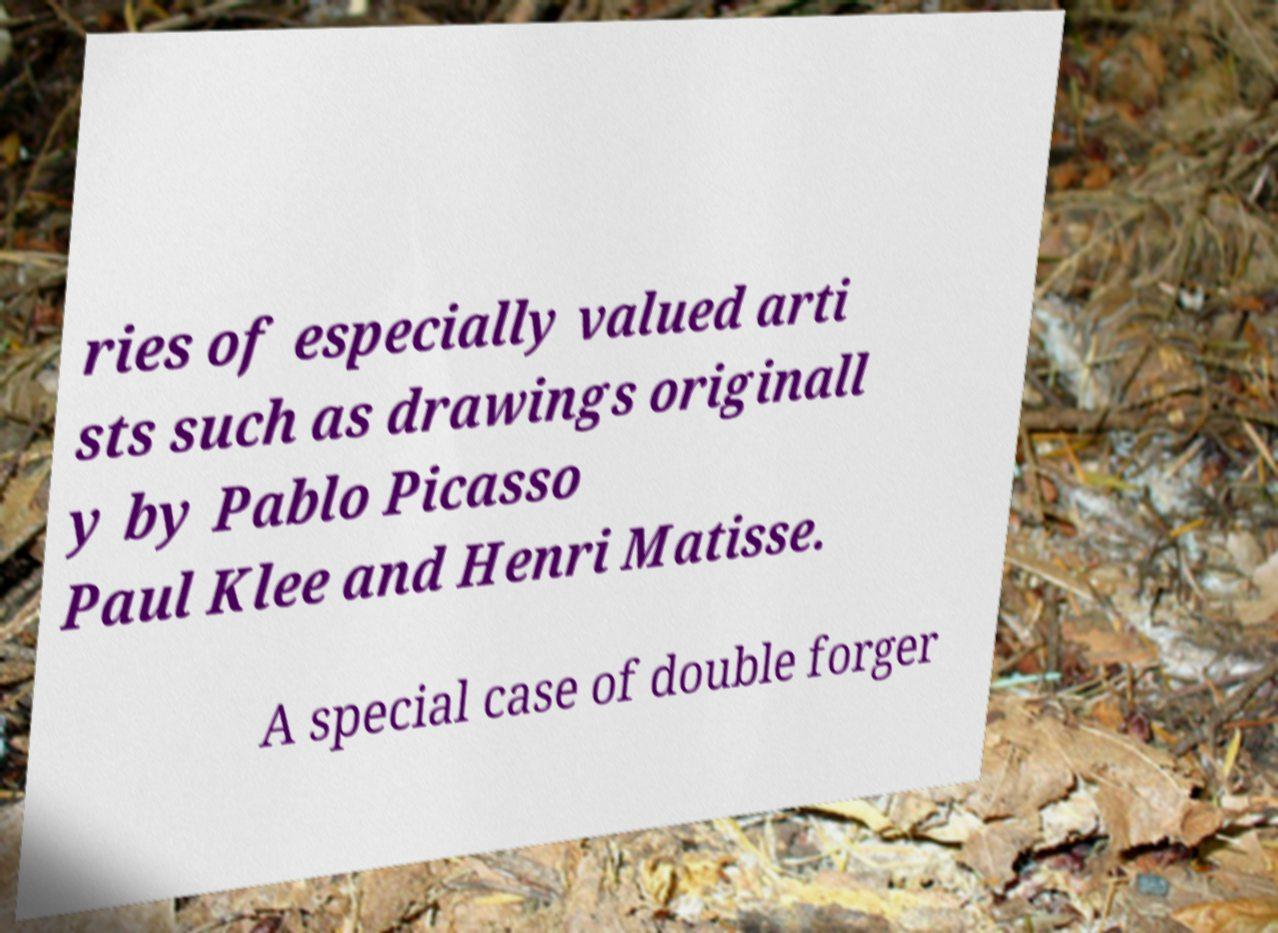Can you read and provide the text displayed in the image?This photo seems to have some interesting text. Can you extract and type it out for me? ries of especially valued arti sts such as drawings originall y by Pablo Picasso Paul Klee and Henri Matisse. A special case of double forger 